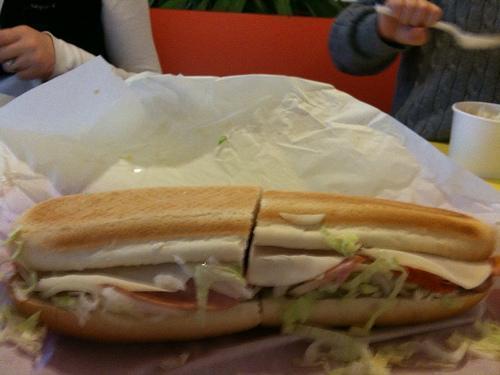How many spoons do you see?
Give a very brief answer. 1. How many sandwiches are in the picture?
Give a very brief answer. 1. How many people are there?
Give a very brief answer. 2. 